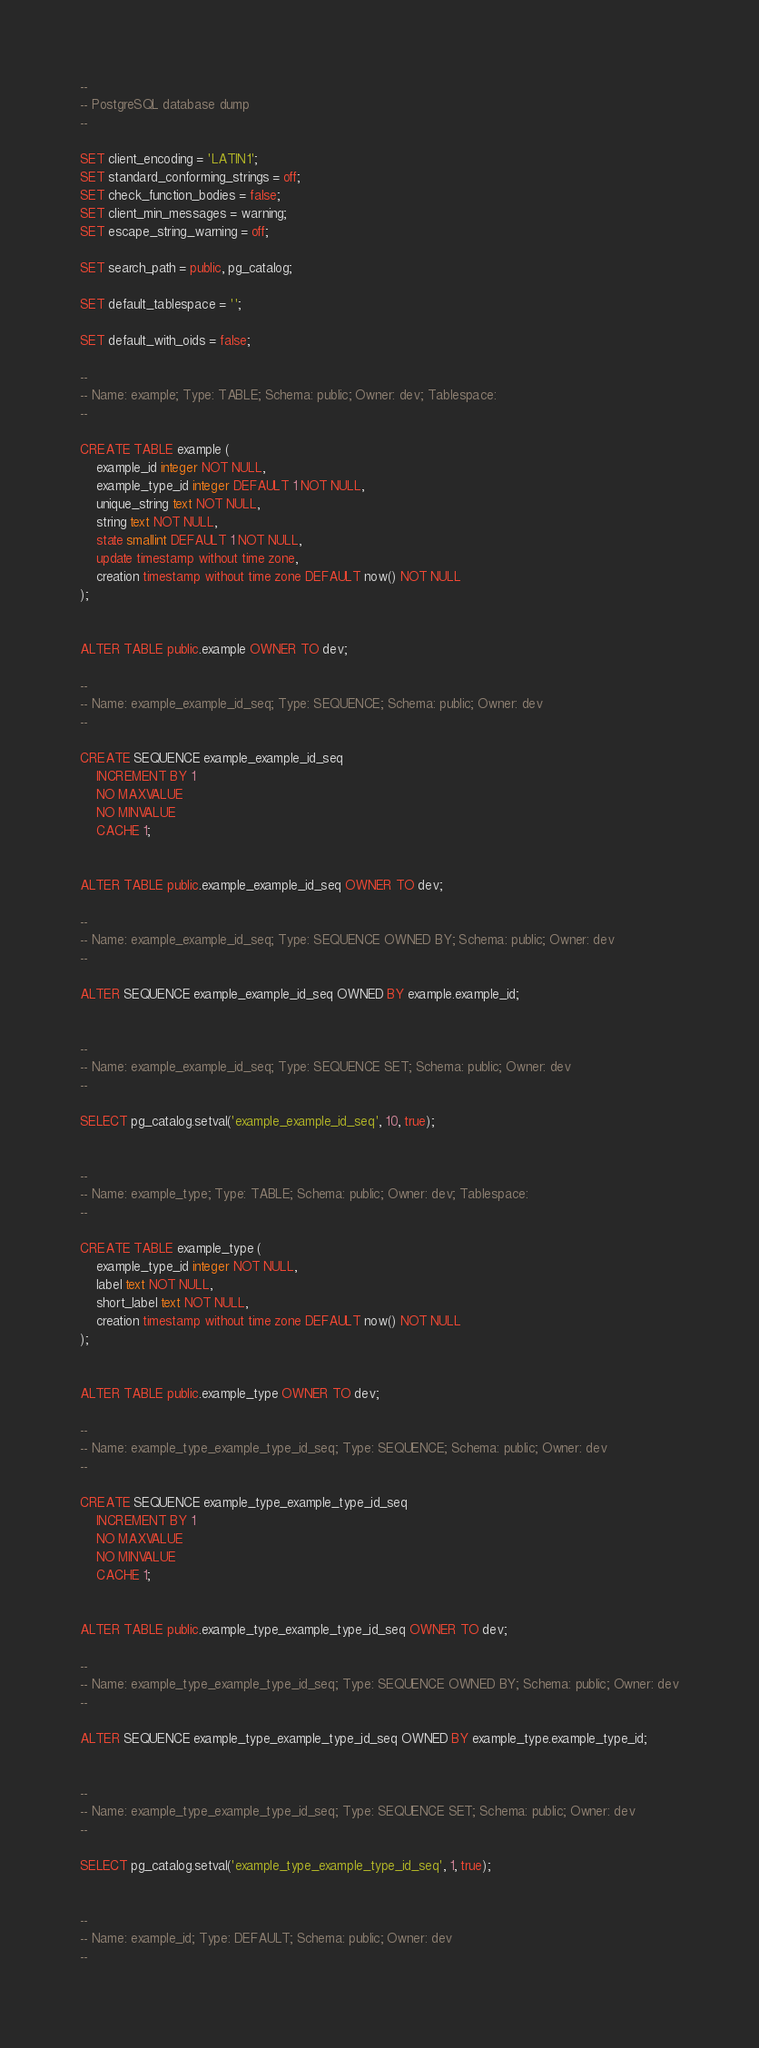<code> <loc_0><loc_0><loc_500><loc_500><_SQL_>--
-- PostgreSQL database dump
--

SET client_encoding = 'LATIN1';
SET standard_conforming_strings = off;
SET check_function_bodies = false;
SET client_min_messages = warning;
SET escape_string_warning = off;

SET search_path = public, pg_catalog;

SET default_tablespace = '';

SET default_with_oids = false;

--
-- Name: example; Type: TABLE; Schema: public; Owner: dev; Tablespace: 
--

CREATE TABLE example (
    example_id integer NOT NULL,
    example_type_id integer DEFAULT 1 NOT NULL,
    unique_string text NOT NULL,
    string text NOT NULL,
    state smallint DEFAULT 1 NOT NULL,
    update timestamp without time zone,
    creation timestamp without time zone DEFAULT now() NOT NULL
);


ALTER TABLE public.example OWNER TO dev;

--
-- Name: example_example_id_seq; Type: SEQUENCE; Schema: public; Owner: dev
--

CREATE SEQUENCE example_example_id_seq
    INCREMENT BY 1
    NO MAXVALUE
    NO MINVALUE
    CACHE 1;


ALTER TABLE public.example_example_id_seq OWNER TO dev;

--
-- Name: example_example_id_seq; Type: SEQUENCE OWNED BY; Schema: public; Owner: dev
--

ALTER SEQUENCE example_example_id_seq OWNED BY example.example_id;


--
-- Name: example_example_id_seq; Type: SEQUENCE SET; Schema: public; Owner: dev
--

SELECT pg_catalog.setval('example_example_id_seq', 10, true);


--
-- Name: example_type; Type: TABLE; Schema: public; Owner: dev; Tablespace: 
--

CREATE TABLE example_type (
    example_type_id integer NOT NULL,
    label text NOT NULL,
    short_label text NOT NULL,
    creation timestamp without time zone DEFAULT now() NOT NULL
);


ALTER TABLE public.example_type OWNER TO dev;

--
-- Name: example_type_example_type_id_seq; Type: SEQUENCE; Schema: public; Owner: dev
--

CREATE SEQUENCE example_type_example_type_id_seq
    INCREMENT BY 1
    NO MAXVALUE
    NO MINVALUE
    CACHE 1;


ALTER TABLE public.example_type_example_type_id_seq OWNER TO dev;

--
-- Name: example_type_example_type_id_seq; Type: SEQUENCE OWNED BY; Schema: public; Owner: dev
--

ALTER SEQUENCE example_type_example_type_id_seq OWNED BY example_type.example_type_id;


--
-- Name: example_type_example_type_id_seq; Type: SEQUENCE SET; Schema: public; Owner: dev
--

SELECT pg_catalog.setval('example_type_example_type_id_seq', 1, true);


--
-- Name: example_id; Type: DEFAULT; Schema: public; Owner: dev
--
</code> 